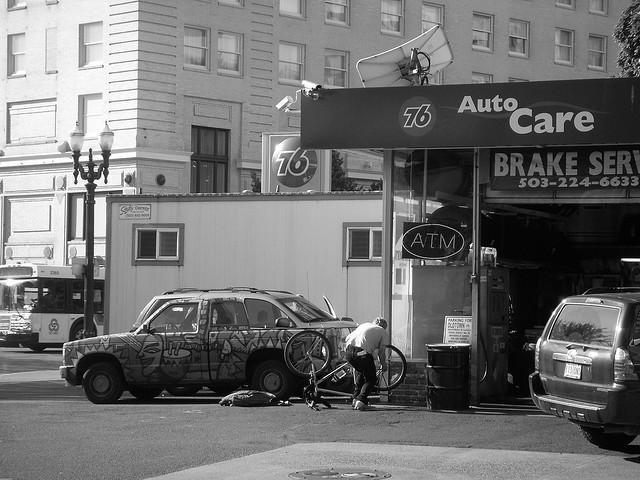How many cars are visible?
Give a very brief answer. 2. 